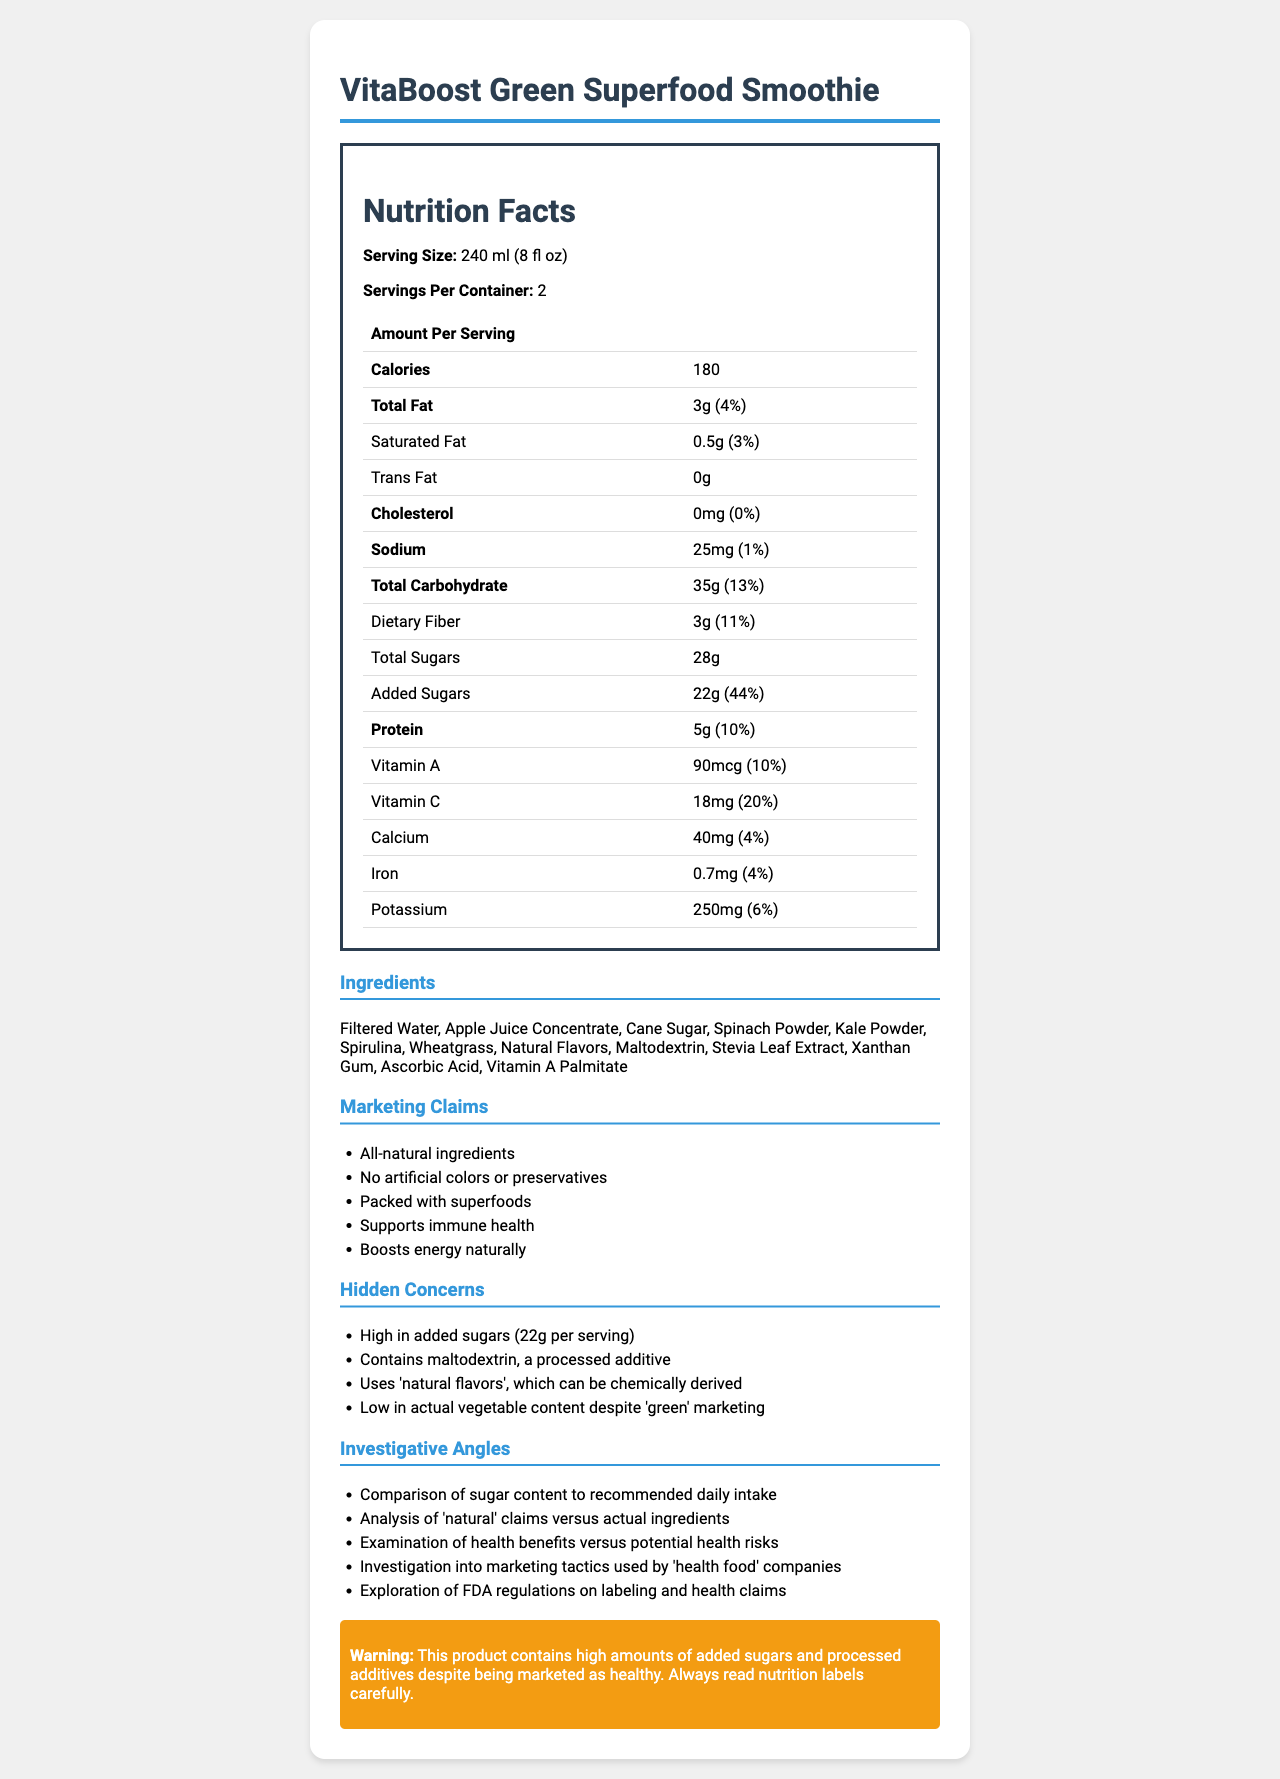what is the serving size of "VitaBoost Green Superfood Smoothie"? The serving size is clearly stated in the document under the section titled "Serving Size."
Answer: 240 ml (8 fl oz) How many servings are there per container? The document mentions "Servings Per Container" as 2.
Answer: 2 How many calories are there per serving? The document lists the calorie count as 180 in the Nutrition Facts table.
Answer: 180 What is the total amount of sugars per serving? The total sugars per serving are listed as 28g in the Nutrition Facts table.
Answer: 28g Which ingredient is listed first in the ingredients list? The document lists ingredients in descending order by weight, with "Filtered Water" appearing first.
Answer: Filtered Water How does the amount of added sugars compare to the total sugars per serving? A. Added sugars are more than total sugars B. Added sugars are less than total sugars C. Added sugars and total sugars are the same The document shows that out of the 28g of total sugars, 22g are added sugars, thus added sugars are less than total sugars.
Answer: B Which of the following is NOT a marketing claim for the product? A. Supports immune health B. Contains zero sugars C. All-natural ingredients The product does not claim to contain zero sugars; rather, it has high added sugar content.
Answer: B Is the product high in dietary fiber? The dietary fiber content is 3g, which is 11% of the daily value, indicating a relatively high amount.
Answer: Yes Summarize the main health concern associated with this product. The product’s high added sugar content and inclusion of processed ingredients contradict its healthy marketing claims, highlighting potential health risks.
Answer: Despite being marketed as a healthy product, the VitaBoost Green Superfood Smoothie contains high levels of added sugars and several processed additives like maltodextrin and 'natural flavors' that might be chemically derived. How much protein is there per serving? The document lists protein content as 5g per serving in the Nutrition Facts.
Answer: 5g What is the source of sweetness in the product? The ingredients list mentions Apple Juice Concentrate, Cane Sugar, and Stevia Leaf Extract as sources of sweetness.
Answer: Apple Juice Concentrate, Cane Sugar, Stevia Leaf Extract Is the amount of sodium in the product significant in terms of daily value? The sodium content is 25mg, which is only 1% of the daily value, indicating it's not a significant amount.
Answer: No How does the product match its claim of 'all-natural ingredients'? While the product contains superfood powders and natural sweeteners, processed additives that may not align with the 'all-natural' claim are included.
Answer: The product contains some natural ingredients but also includes processed additives like maltodextrin and natural flavors, which can be chemically derived. How credible is the claim that it is 'packed with superfoods'? The product contains powders of spinach, kale, spirulina, and wheatgrass, but these are not the main ingredients, overshadowed by higher quantities of water, apple juice concentrate, and cane sugar.
Answer: Not very credible Can the exact amount of actual vegetable content be determined from the document? The document lists certain vegetable powders but does not quantify their amounts, making it impossible to determine the exact vegetable content.
Answer: Not enough information What percentage of the daily value of Vitamin C does each serving provide? The document states that each serving provides 18mg of Vitamin C, which is 20% of the daily value.
Answer: 20% Based on the nutrition facts and ingredients list, should this product be categorized as low-added-sugar? Each serving contains 22g of added sugars, which is 44% of the daily value, classifying it as high in added sugars.
Answer: No 